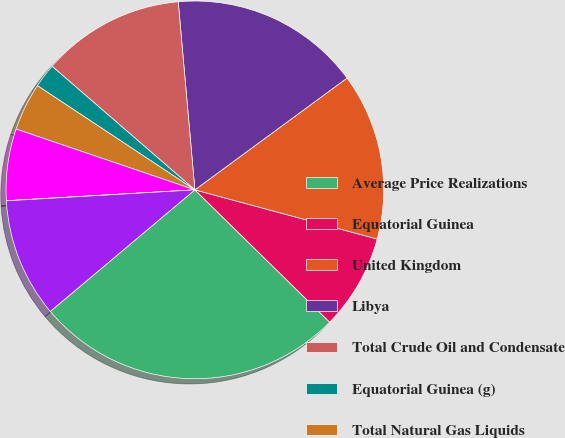Convert chart. <chart><loc_0><loc_0><loc_500><loc_500><pie_chart><fcel>Average Price Realizations<fcel>Equatorial Guinea<fcel>United Kingdom<fcel>Libya<fcel>Total Crude Oil and Condensate<fcel>Equatorial Guinea (g)<fcel>Total Natural Gas Liquids<fcel>Total Liquid Hydrocarbons<fcel>Total Natural Gas<fcel>Synthetic Crude Oil (per bbl)<nl><fcel>26.52%<fcel>8.16%<fcel>14.28%<fcel>16.32%<fcel>12.24%<fcel>2.05%<fcel>4.09%<fcel>6.13%<fcel>0.01%<fcel>10.2%<nl></chart> 